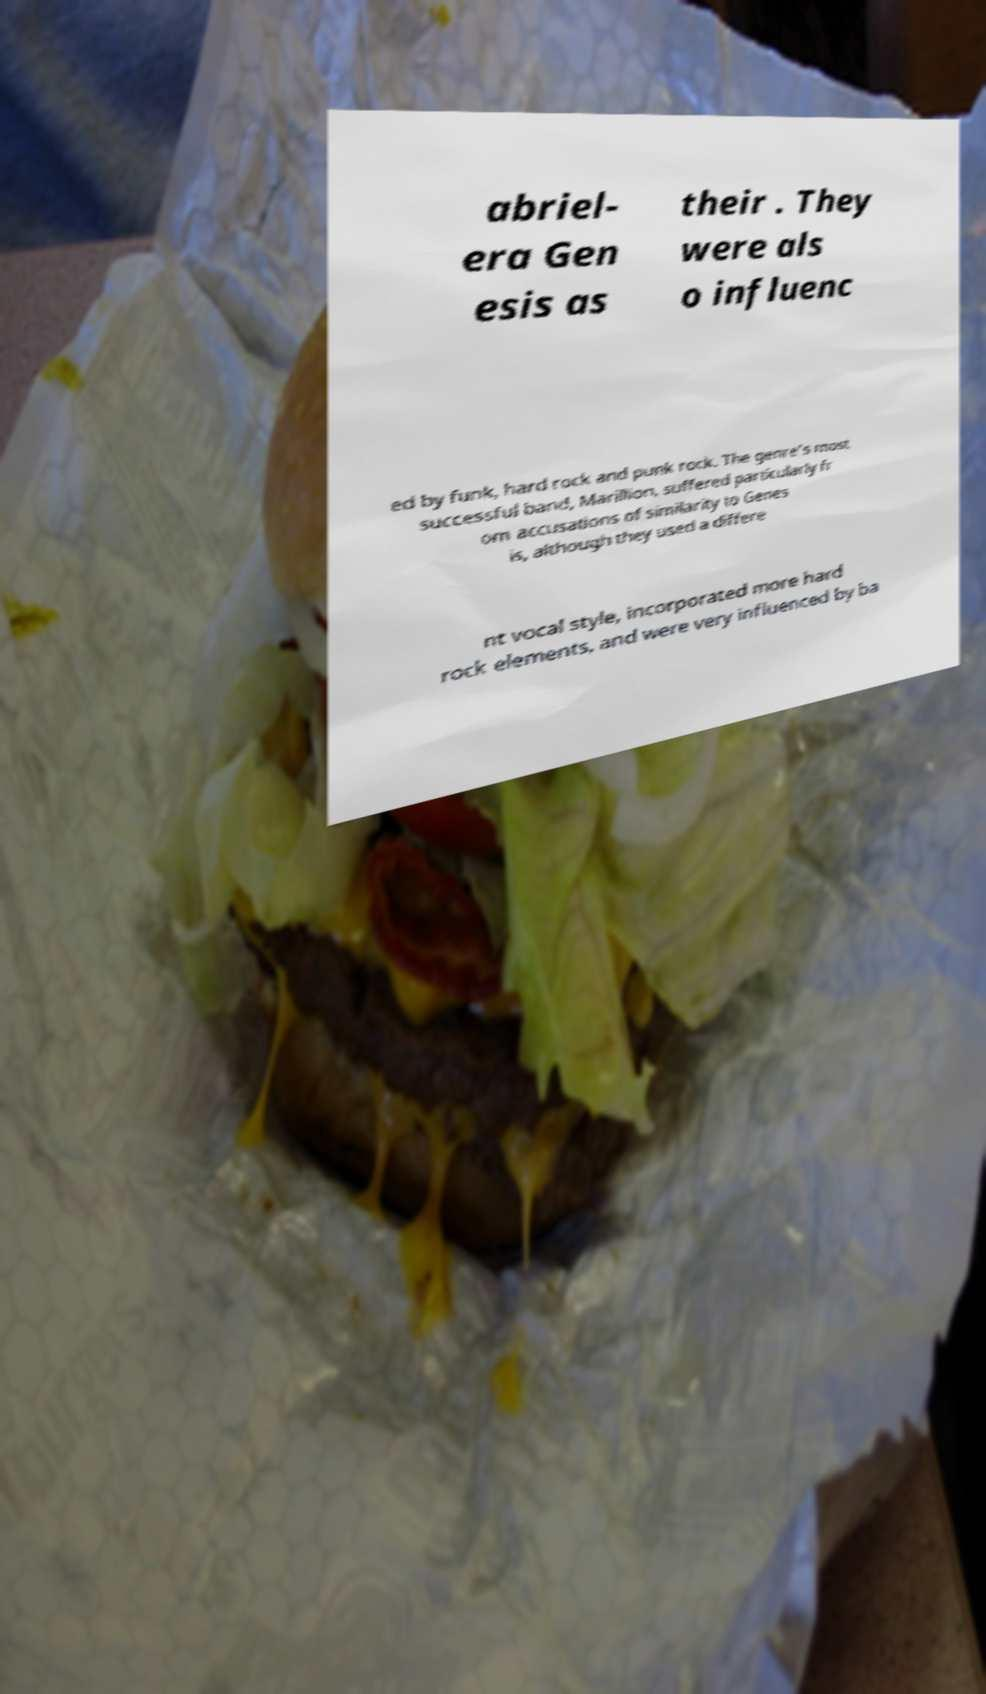I need the written content from this picture converted into text. Can you do that? abriel- era Gen esis as their . They were als o influenc ed by funk, hard rock and punk rock. The genre's most successful band, Marillion, suffered particularly fr om accusations of similarity to Genes is, although they used a differe nt vocal style, incorporated more hard rock elements, and were very influenced by ba 